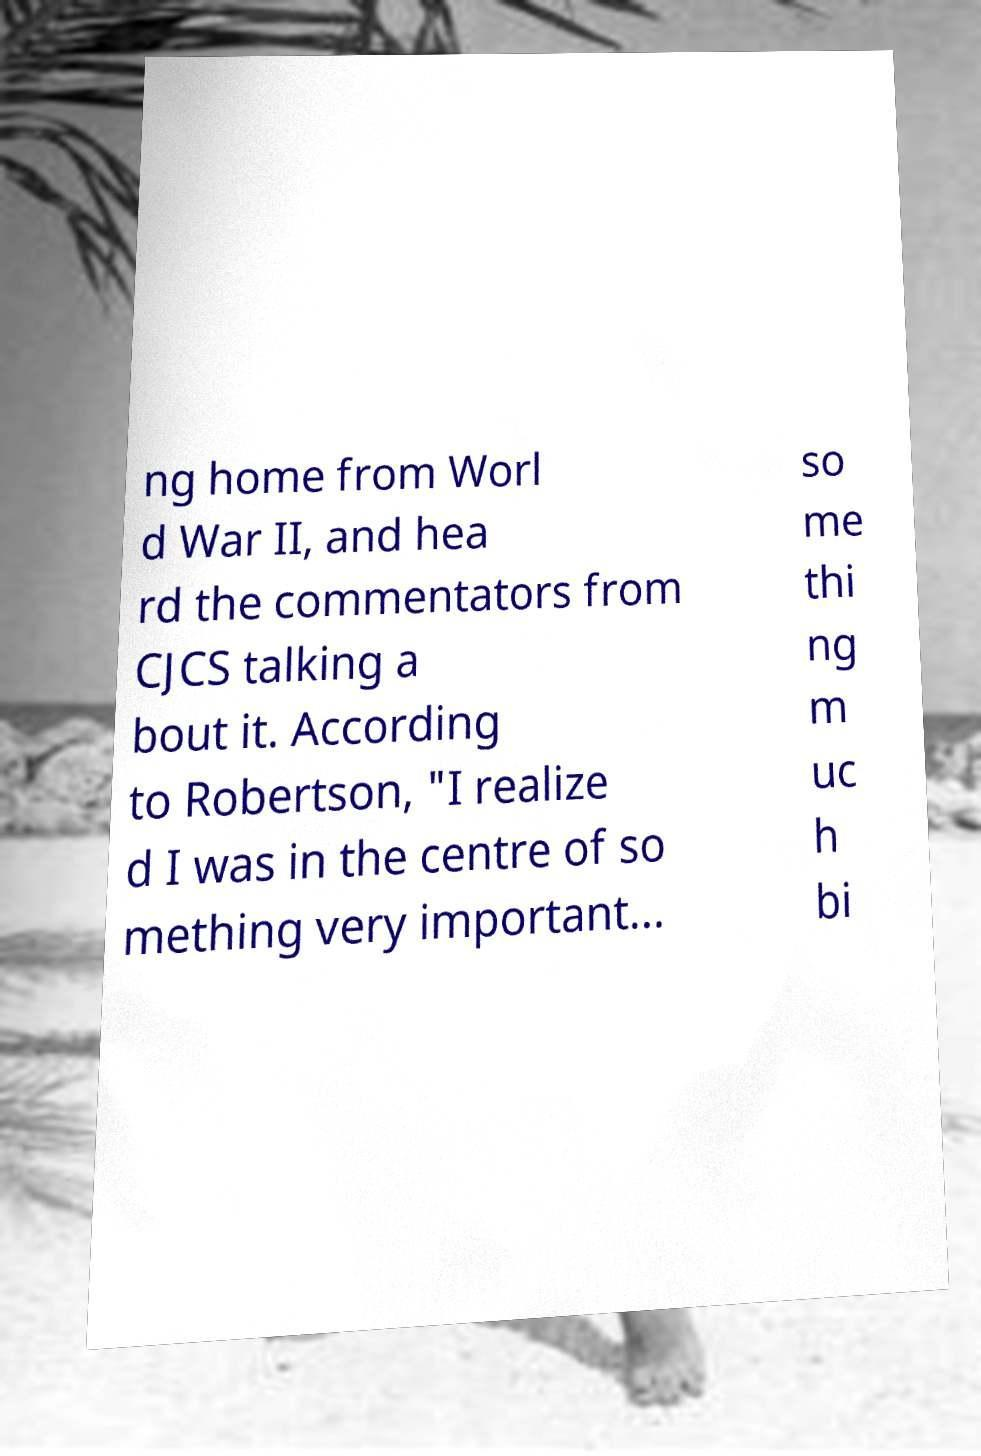Please read and relay the text visible in this image. What does it say? ng home from Worl d War II, and hea rd the commentators from CJCS talking a bout it. According to Robertson, "I realize d I was in the centre of so mething very important... so me thi ng m uc h bi 